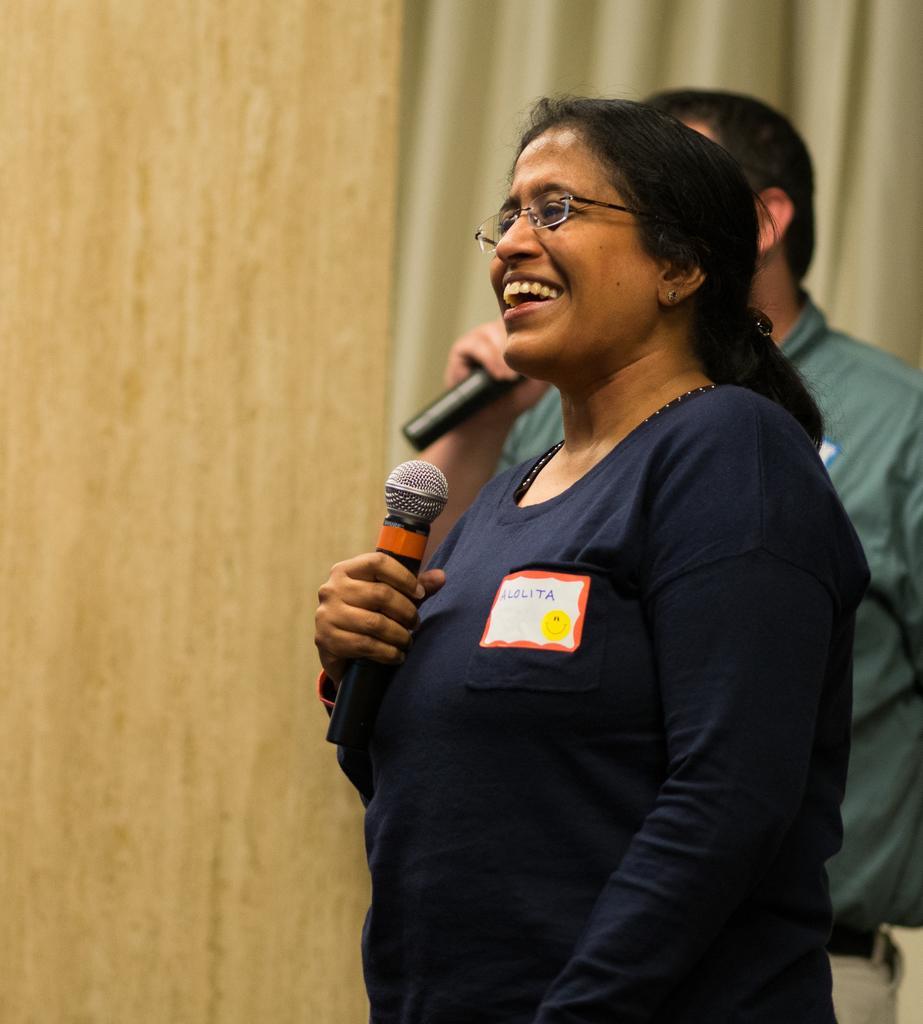Can you describe this image briefly? On the right side, there is a person in violet color shirt, wearing spectacle, smiling, standing and holding a mic. In the background, there is another person standing and holding a mic, there is a curtain and there is wall. 